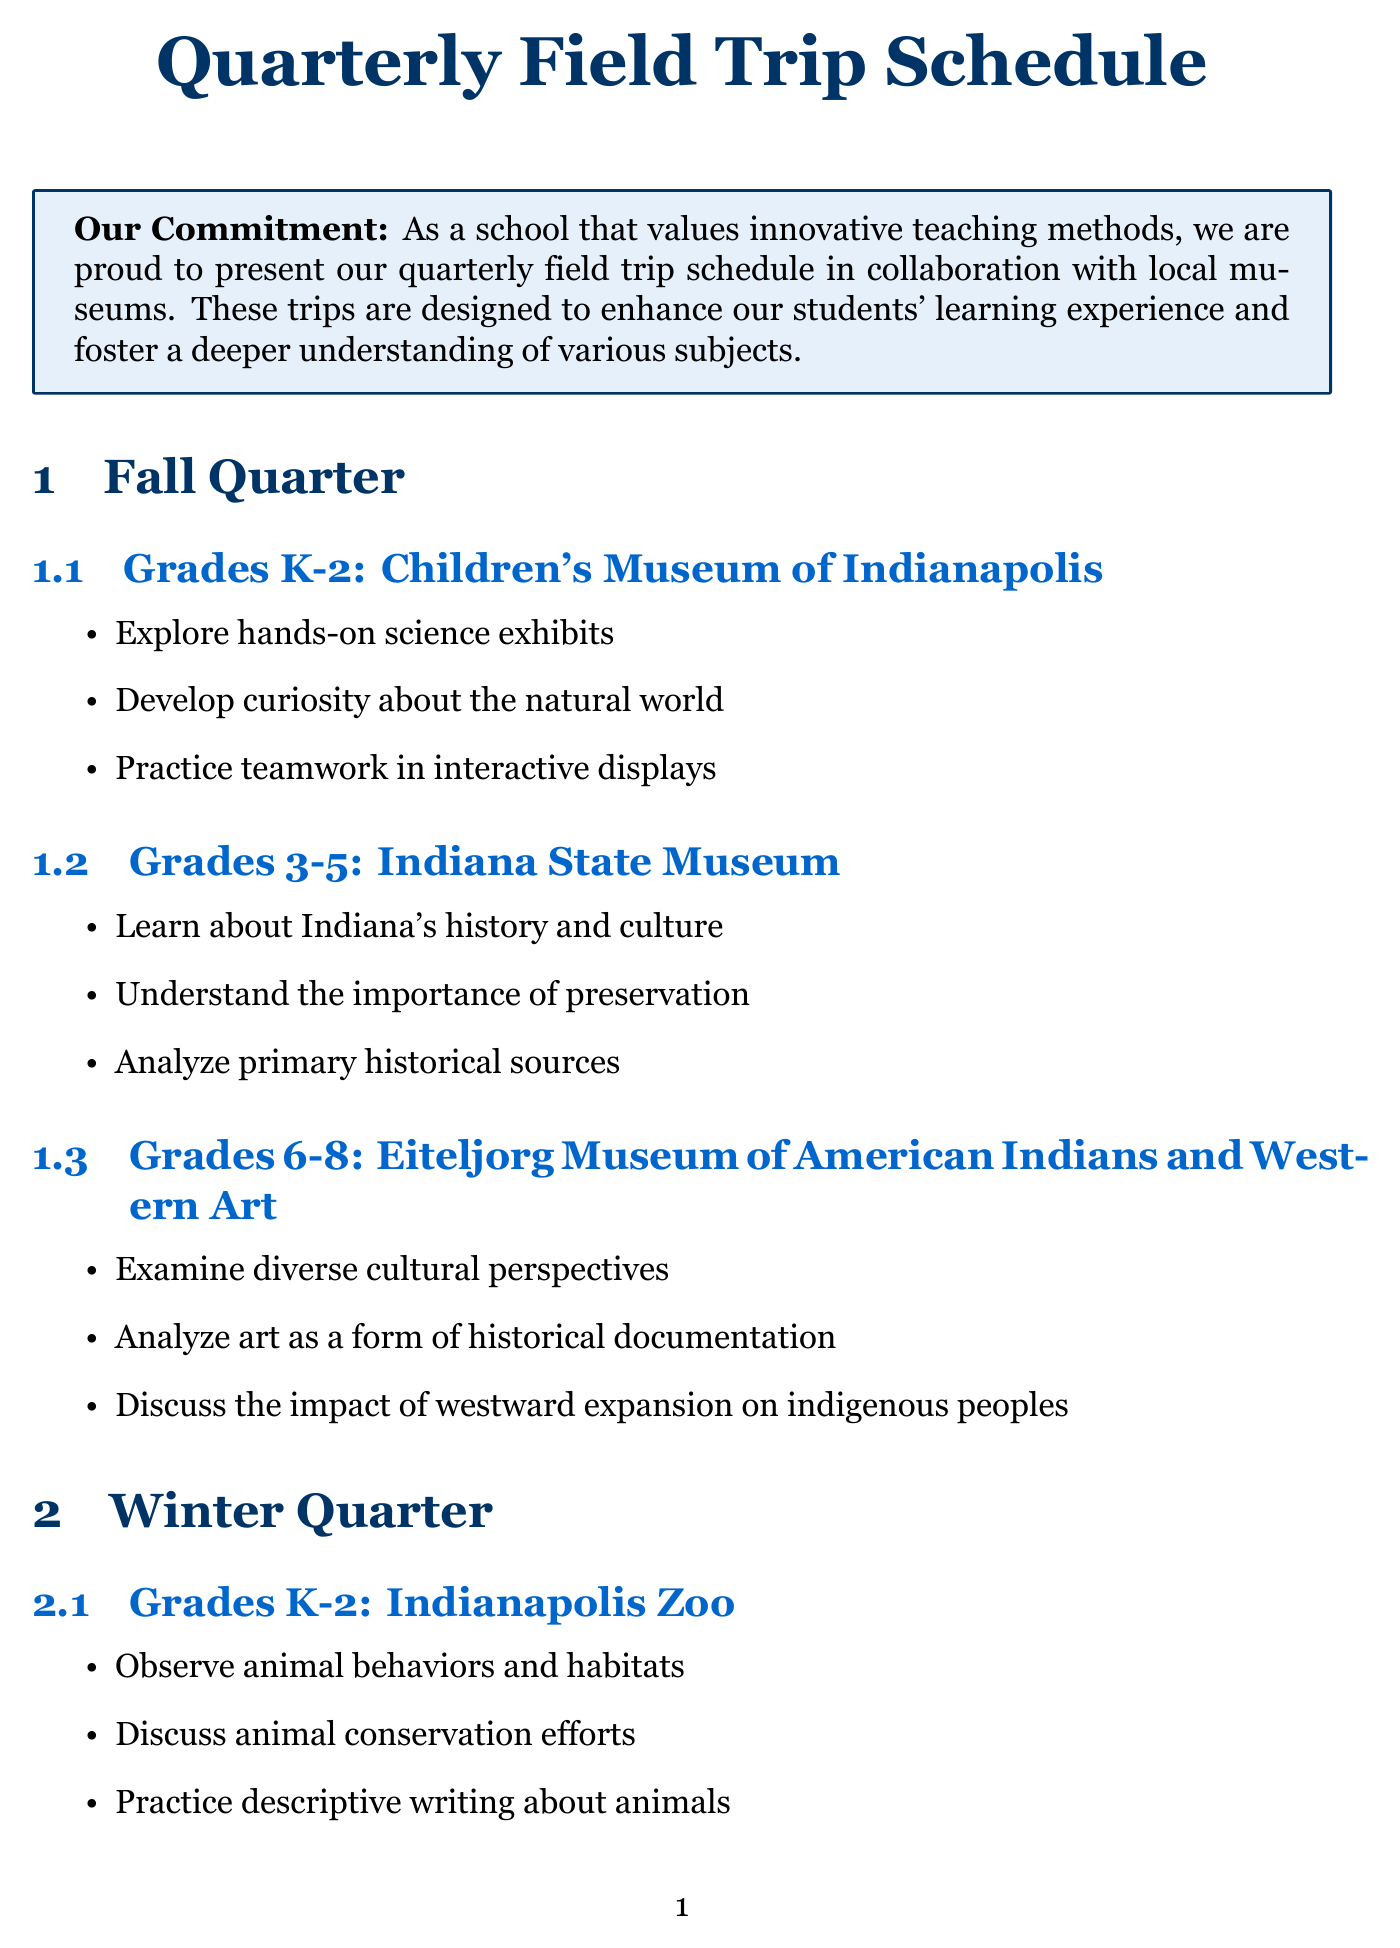What museum is scheduled for grades K-2 in the Fall? The document specifies that the Children's Museum of Indianapolis is the scheduled museum for grades K-2 in the Fall quarter.
Answer: Children's Museum of Indianapolis What is one objective for grades 3-5 during the Winter trip? The objectives listed for grades 3-5 during the Winter trip to the Indiana Medical History Museum include exploring the history of medicine.
Answer: Explore the history of medicine How many museums are listed for each grade level in the Spring? The document indicates there are three museums listed for each grade level in the Spring quarter, one for each group.
Answer: Three What initiative allows schools to borrow museum artifacts? The document outlines the Artifact Loan Program as the initiative that allows schools to borrow museum artifacts for in-class use.
Answer: Artifact Loan Program Which museum in Summer focuses on automotive technology? The Indianapolis Motor Speedway Museum is designated for grades 6-8 and focuses on the history of automotive technology during the Summer quarter.
Answer: Indianapolis Motor Speedway Museum How many different grade levels are mentioned in the field trips schedule? The field trip schedule includes three different grade levels mentioned: K-2, 3-5, and 6-8.
Answer: Three What is one objective associated with the Conner Prairie trip for grades K-2? One of the objectives is to experience life in 19th century Indiana, according to the objectives listed in the Spring section for grades K-2.
Answer: Experience life in 19th century Indiana Which collaboration initiative enhances leadership skills? The Student Docent Program is the initiative that enhances public speaking and leadership skills among middle school students.
Answer: Student Docent Program 